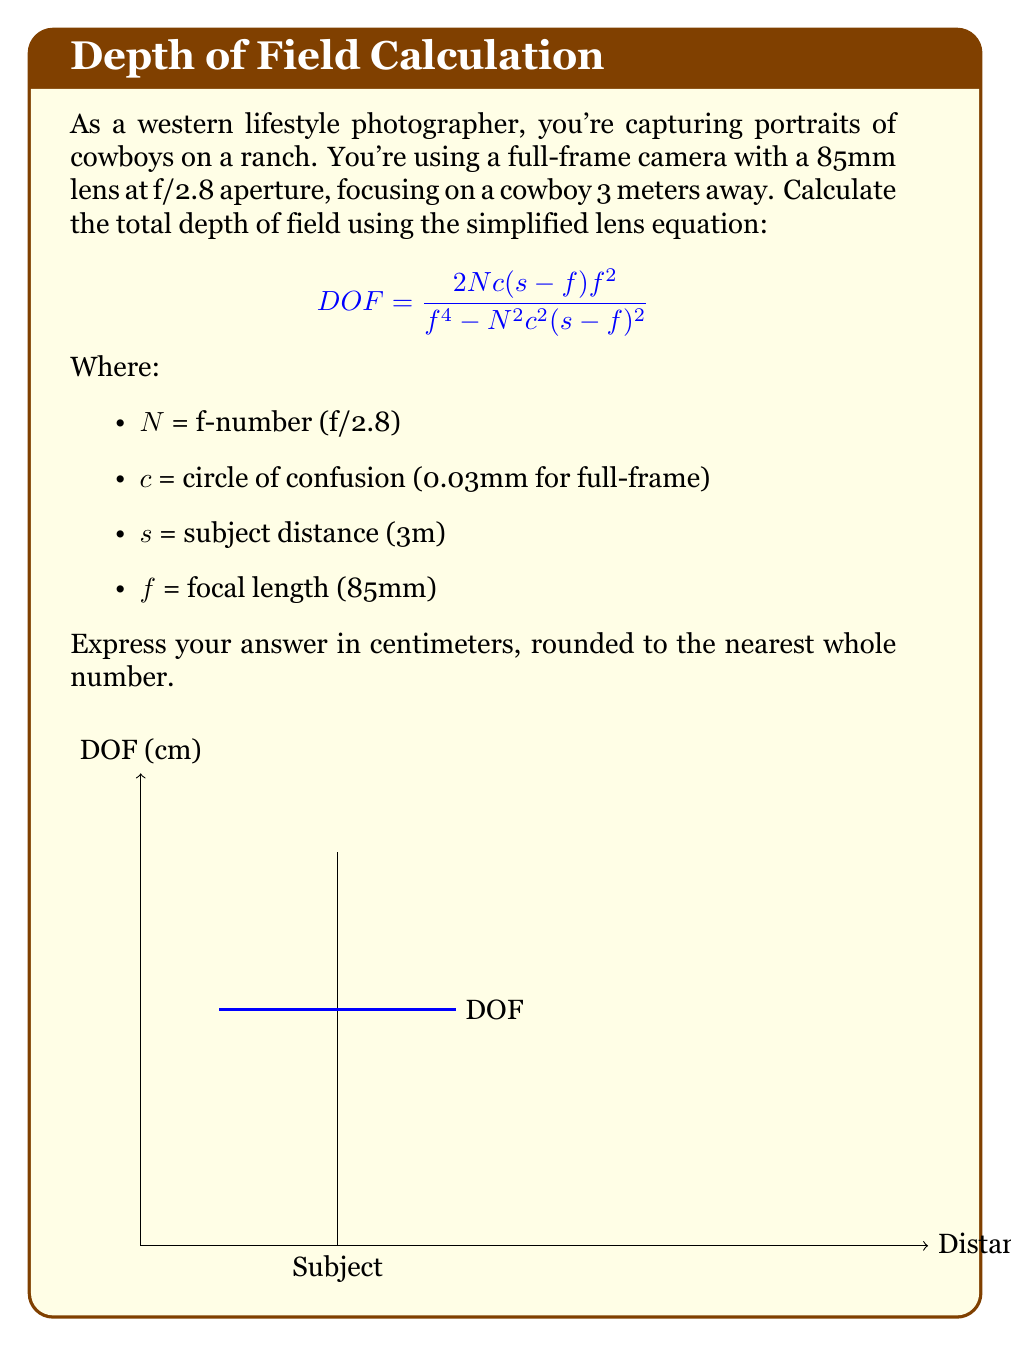Could you help me with this problem? Let's solve this problem step by step:

1) First, we need to convert all measurements to meters:
   f = 85mm = 0.085m
   c = 0.03mm = 0.00003m

2) Now, let's substitute all known values into the DOF equation:

   $$DOF = \frac{2 \cdot 2.8 \cdot 0.00003 \cdot (3-0.085) \cdot 0.085^2}{0.085^4-2.8^2 \cdot 0.00003^2 \cdot (3-0.085)^2}$$

3) Let's calculate the numerator:
   2 * 2.8 * 0.00003 * 2.915 * 0.007225 = 0.0000352989

4) Now the denominator:
   0.085^4 = 0.00000052200625
   2.8^2 * 0.00003^2 * 2.915^2 = 0.000000000191362404
   0.00000052200625 - 0.000000000191362404 = 0.000000521814887596

5) Dividing numerator by denominator:
   0.0000352989 / 0.000000521814887596 = 0.0676616 meters

6) Convert to centimeters:
   0.0676616 * 100 = 6.76616 cm

7) Rounding to the nearest whole number:
   6.76616 ≈ 7 cm
Answer: 7 cm 